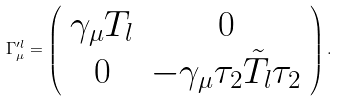Convert formula to latex. <formula><loc_0><loc_0><loc_500><loc_500>\Gamma _ { \mu } ^ { \prime l } = \left ( \begin{array} { c c } \gamma _ { \mu } T _ { l } & 0 \\ 0 & - \gamma _ { \mu } \tau _ { 2 } \tilde { T } _ { l } \tau _ { 2 } \end{array} \right ) .</formula> 